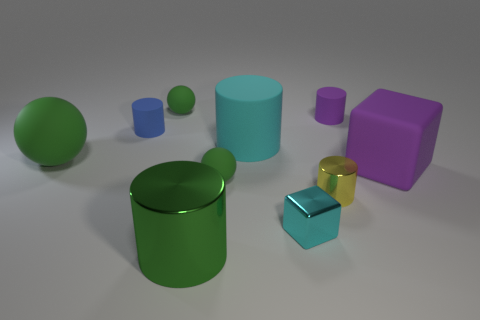Subtract all purple blocks. How many blocks are left? 1 Subtract all blue matte cylinders. How many cylinders are left? 4 Subtract 1 cubes. How many cubes are left? 1 Subtract all balls. How many objects are left? 7 Subtract all gray spheres. How many red cylinders are left? 0 Subtract all large purple rubber blocks. Subtract all big cyan objects. How many objects are left? 8 Add 8 tiny matte cylinders. How many tiny matte cylinders are left? 10 Add 7 purple matte cylinders. How many purple matte cylinders exist? 8 Subtract 0 yellow blocks. How many objects are left? 10 Subtract all blue cylinders. Subtract all blue balls. How many cylinders are left? 4 